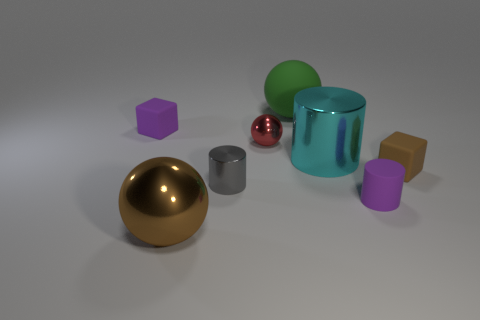Subtract all big metal spheres. How many spheres are left? 2 Add 1 green matte spheres. How many objects exist? 9 Subtract 2 cubes. How many cubes are left? 0 Subtract all green spheres. How many spheres are left? 2 Subtract 1 cyan cylinders. How many objects are left? 7 Subtract all cylinders. How many objects are left? 5 Subtract all brown blocks. Subtract all brown balls. How many blocks are left? 1 Subtract all yellow cylinders. How many red blocks are left? 0 Subtract all brown cubes. Subtract all large metal objects. How many objects are left? 5 Add 2 small brown matte things. How many small brown matte things are left? 3 